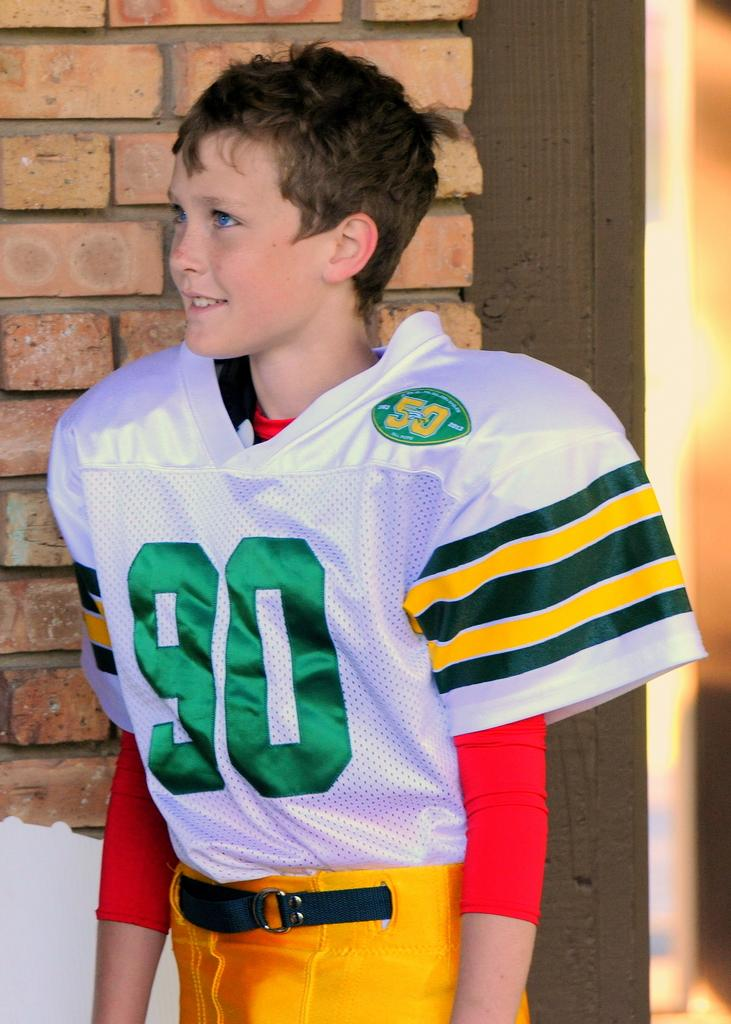<image>
Describe the image concisely. The boy is wearing the green, yellow and white number 90 jersey. 